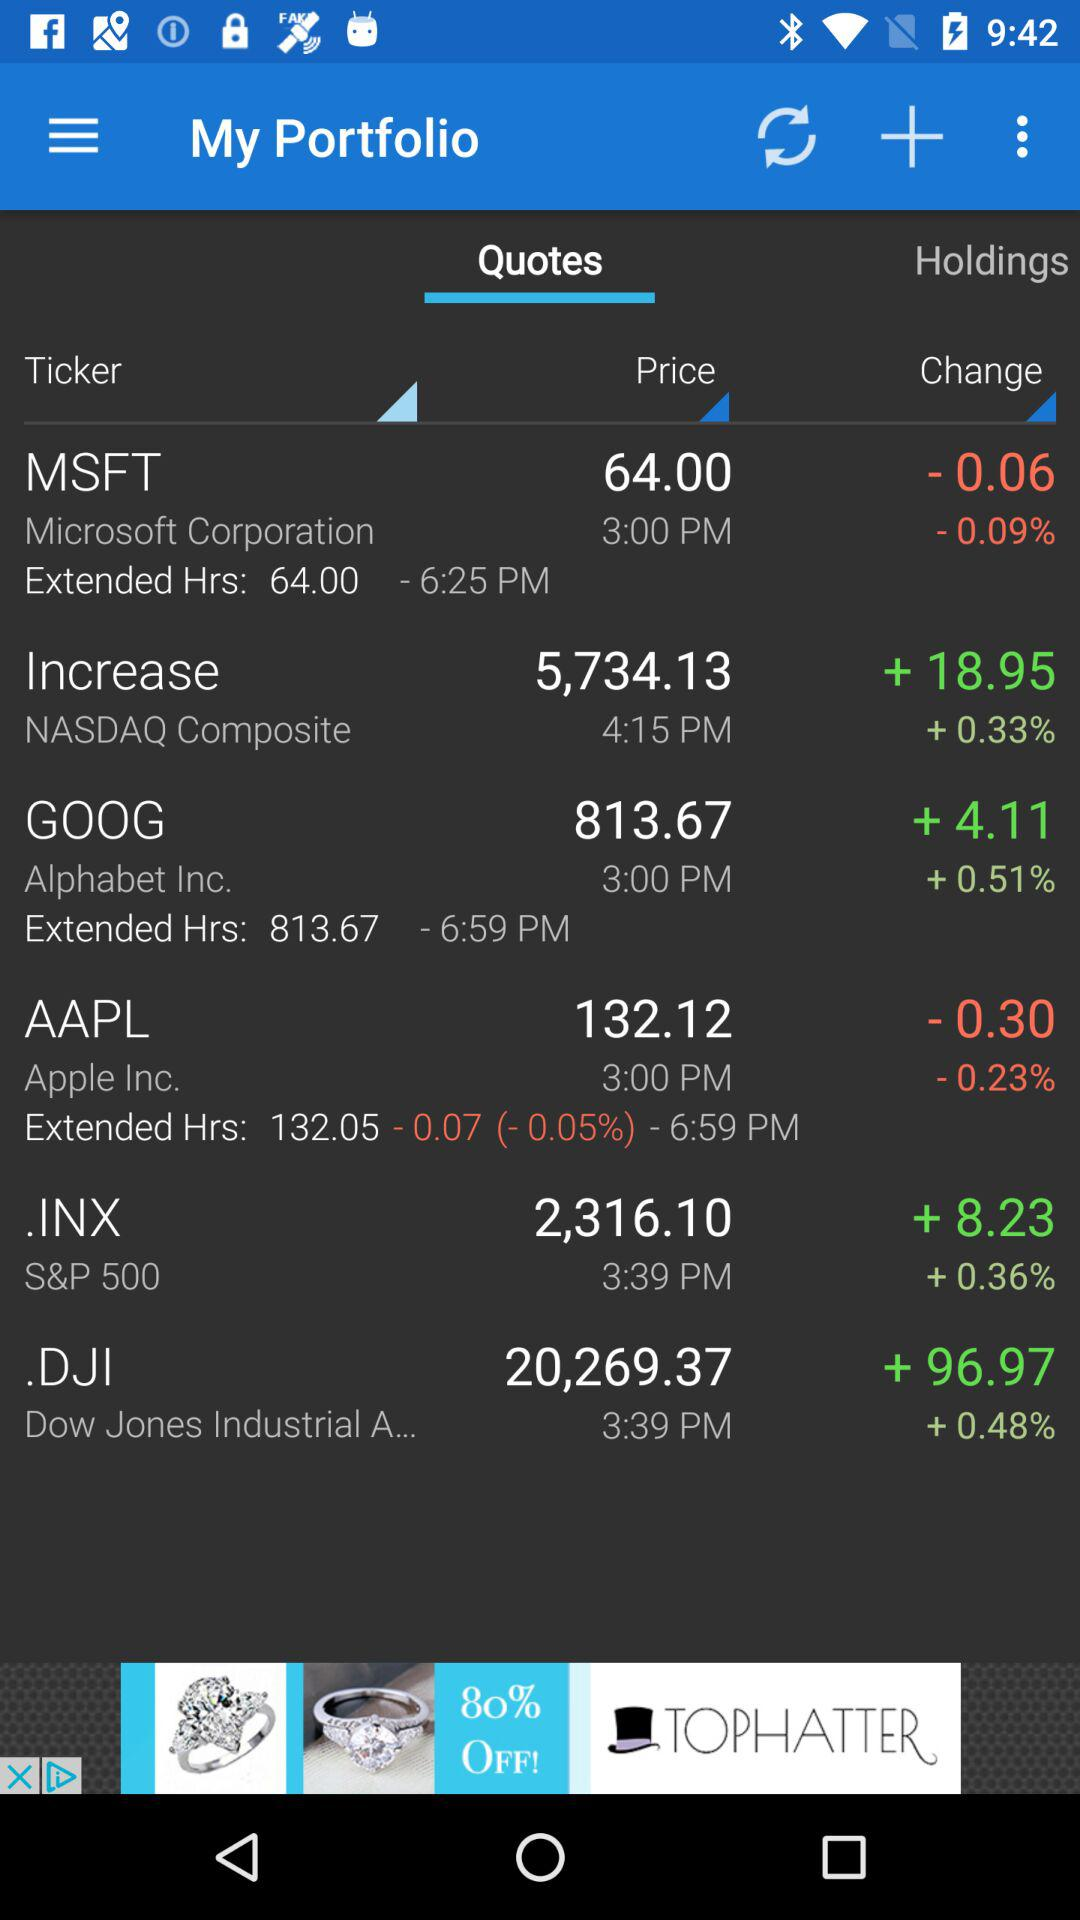When was the price of.DJI last updated? The price of.DJI was last updated at 3:39 p.m. 